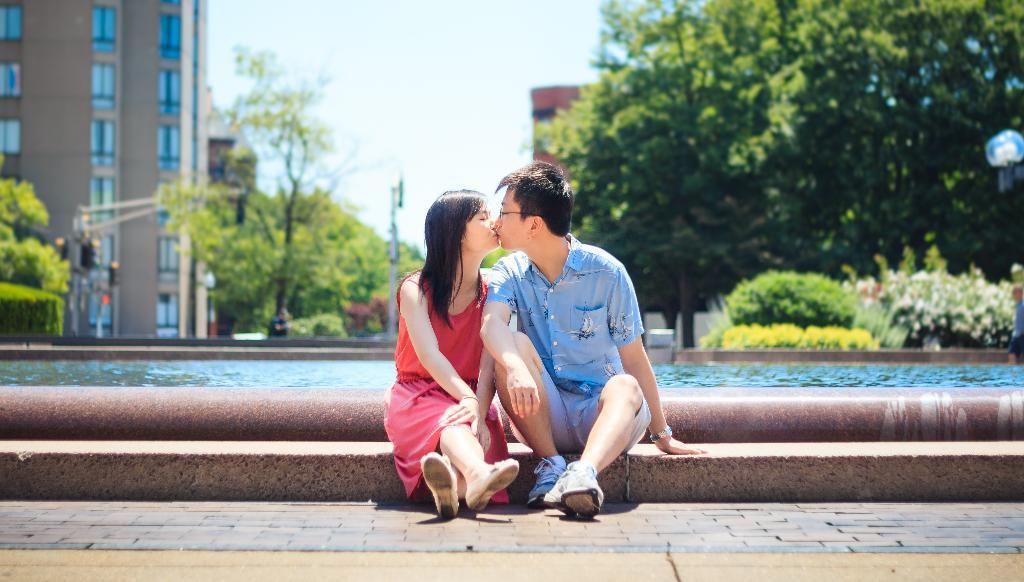Describe this image in one or two sentences. In the middle I can see two persons are sitting on the fence. In the background I can see a pipe, swimming pool, plants, poles, trees and buildings. On the top middle I can see the sky. This image is taken during a day. 